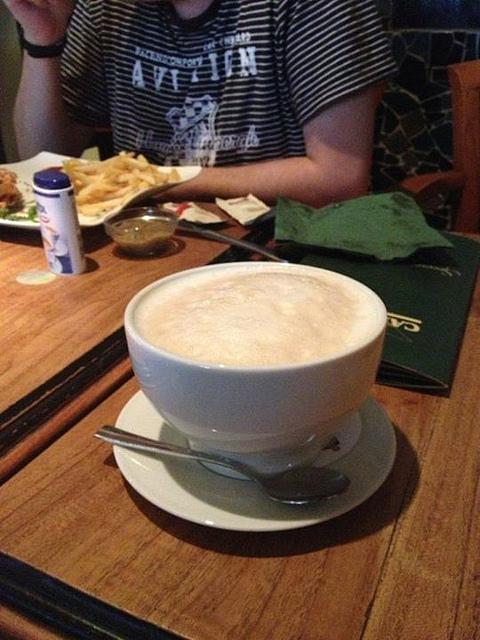Would you eat or drink this?
Write a very short answer. Drink. What utensil will be used to eat this?
Short answer required. Spoon. How many tables are in this pic?
Quick response, please. 2. 